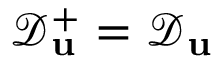<formula> <loc_0><loc_0><loc_500><loc_500>\mathcal { D } _ { u } ^ { + } = \mathcal { D } _ { u }</formula> 